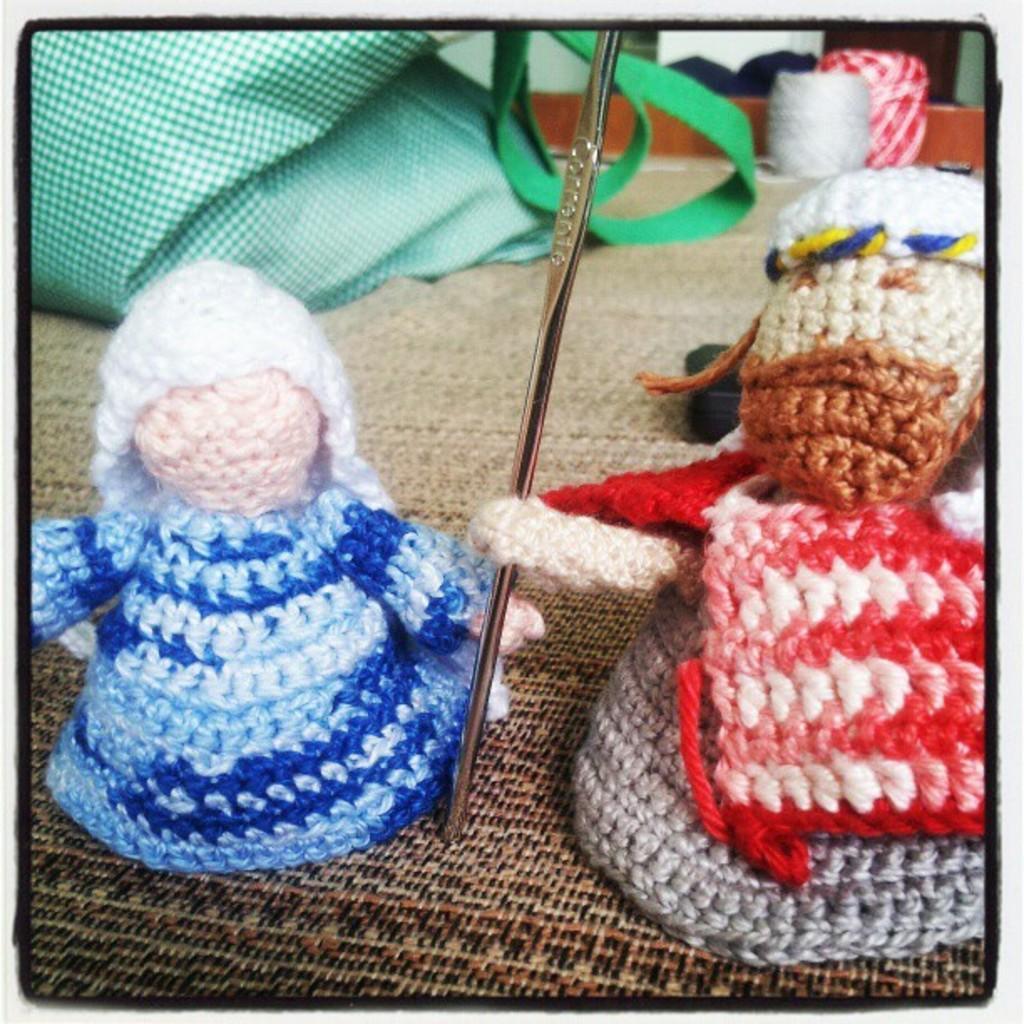Describe this image in one or two sentences. These are the two woolen dolls, in the middle there is a stainless pin. 